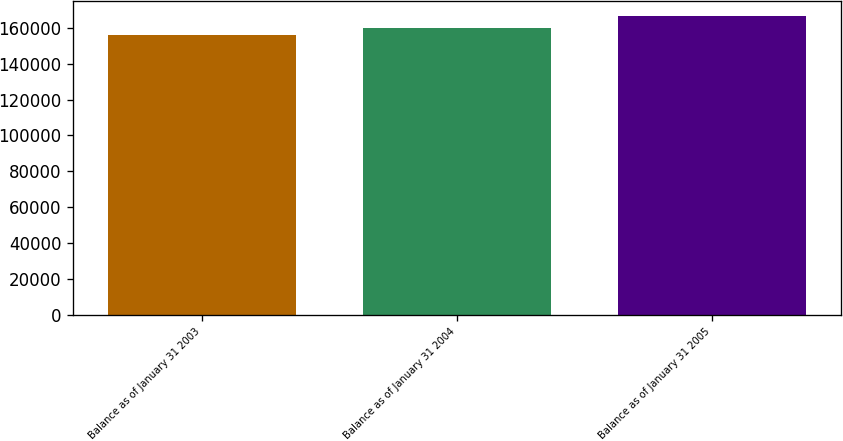Convert chart to OTSL. <chart><loc_0><loc_0><loc_500><loc_500><bar_chart><fcel>Balance as of January 31 2003<fcel>Balance as of January 31 2004<fcel>Balance as of January 31 2005<nl><fcel>155945<fcel>160094<fcel>166628<nl></chart> 